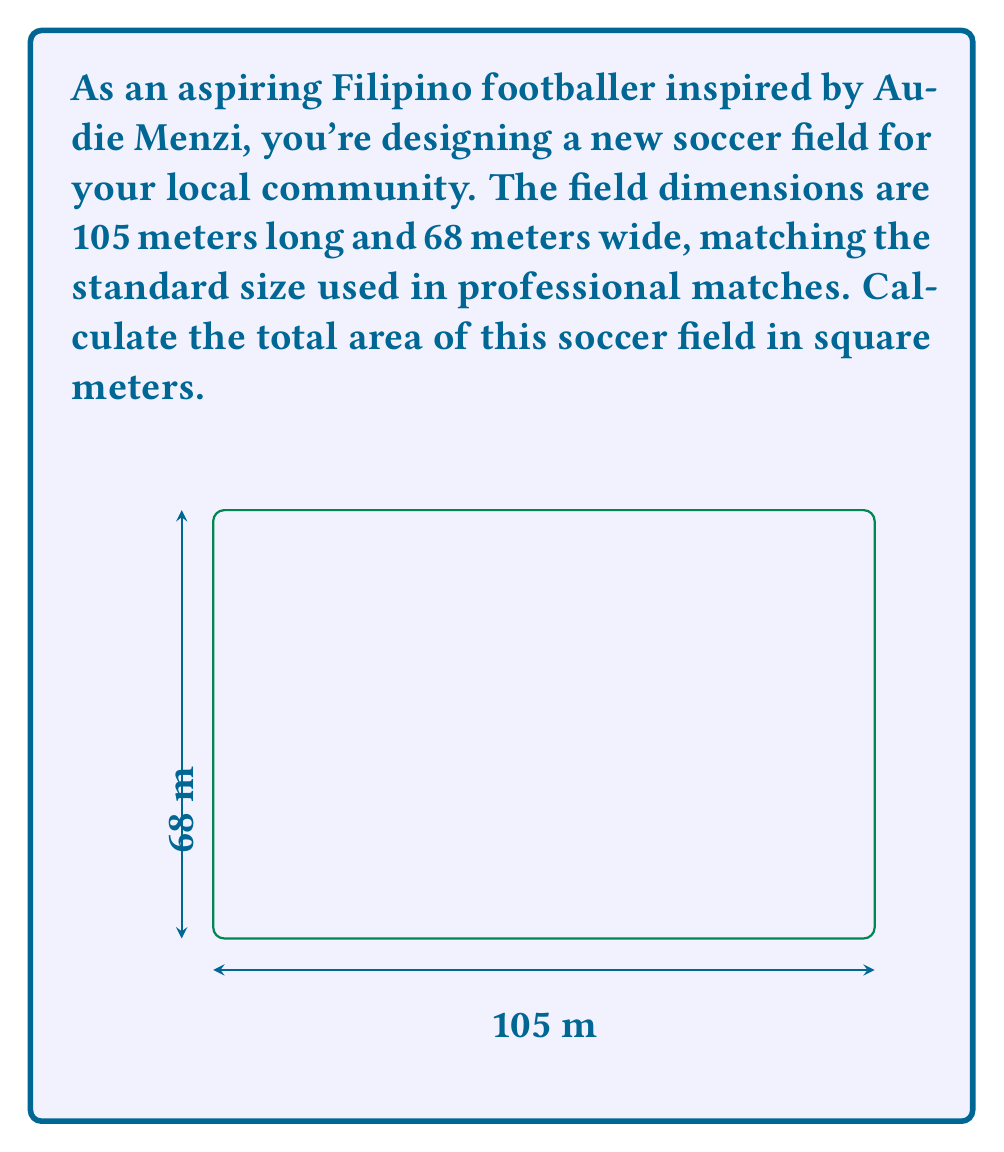Help me with this question. To calculate the area of a rectangular soccer field, we need to multiply its length by its width.

Given:
- Length of the field = 105 meters
- Width of the field = 68 meters

The formula for the area of a rectangle is:

$$A = l \times w$$

Where:
$A$ = Area
$l$ = Length
$w$ = Width

Substituting the values:

$$A = 105 \text{ m} \times 68 \text{ m}$$

Calculating:

$$A = 7,140 \text{ m}^2$$

Therefore, the total area of the soccer field is 7,140 square meters.
Answer: $7,140 \text{ m}^2$ 